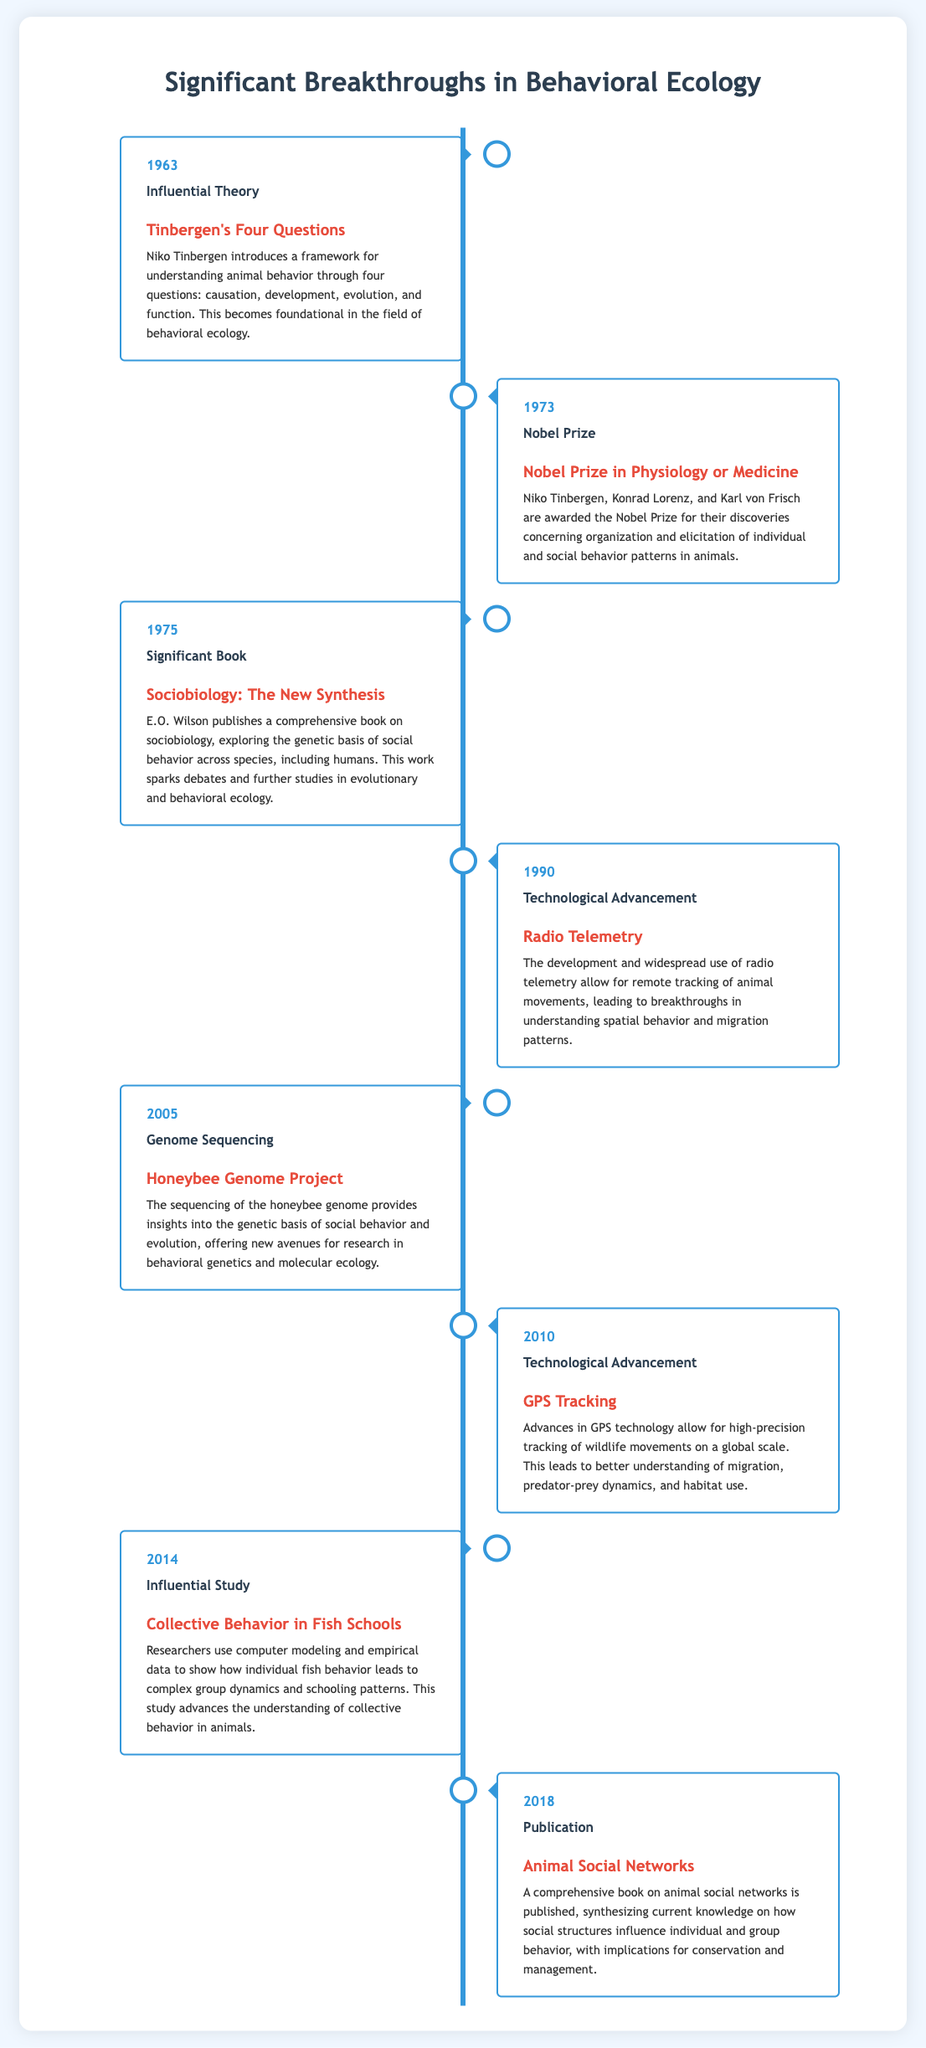What year was Tinbergen's Four Questions introduced? The document states that Tinbergen's Four Questions were introduced in 1963.
Answer: 1963 Who won the Nobel Prize in 1973? The document lists Niko Tinbergen, Konrad Lorenz, and Karl von Frisch as the winners of the Nobel Prize in 1973.
Answer: Niko Tinbergen, Konrad Lorenz, and Karl von Frisch What significant book did E.O. Wilson publish in 1975? The document mentions "Sociobiology: The New Synthesis" as the significant book published by E.O. Wilson in 1975.
Answer: Sociobiology: The New Synthesis What technological advancement occurred in 1990? According to the document, the development and widespread use of radio telemetry is noted as the technological advancement in 1990.
Answer: Radio Telemetry Which project sequenced the honeybee genome? The document refers to the "Honeybee Genome Project" as the project that sequenced the honeybee genome in 2005.
Answer: Honeybee Genome Project What does the study of collective behavior in fish schools illustrate? The document indicates that the study shows how individual fish behavior leads to complex group dynamics and schooling patterns.
Answer: Individual fish behavior In what year did GPS tracking technology advance? The document states that GPS tracking technology advanced in 2010.
Answer: 2010 What is one implication of the book on animal social networks published in 2018? The document mentions that the book has implications for conservation and management, as it synthesizes knowledge on social structures.
Answer: Conservation and management What framework did Tinbergen introduce to understand animal behavior? The document explains that Tinbergen introduced a framework consisting of four questions regarding animal behavior.
Answer: Four questions 